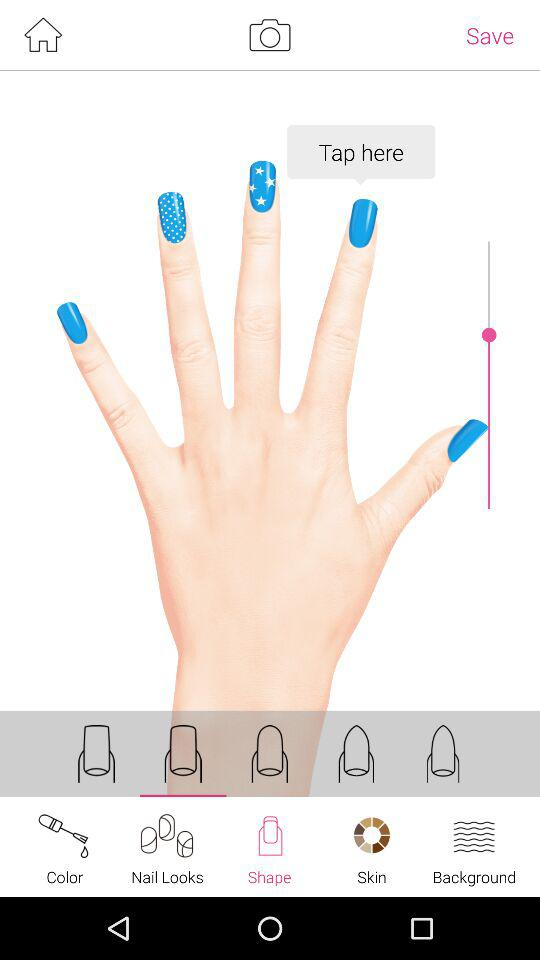Which tab has been selected? The tab "Nails" has been selected. 